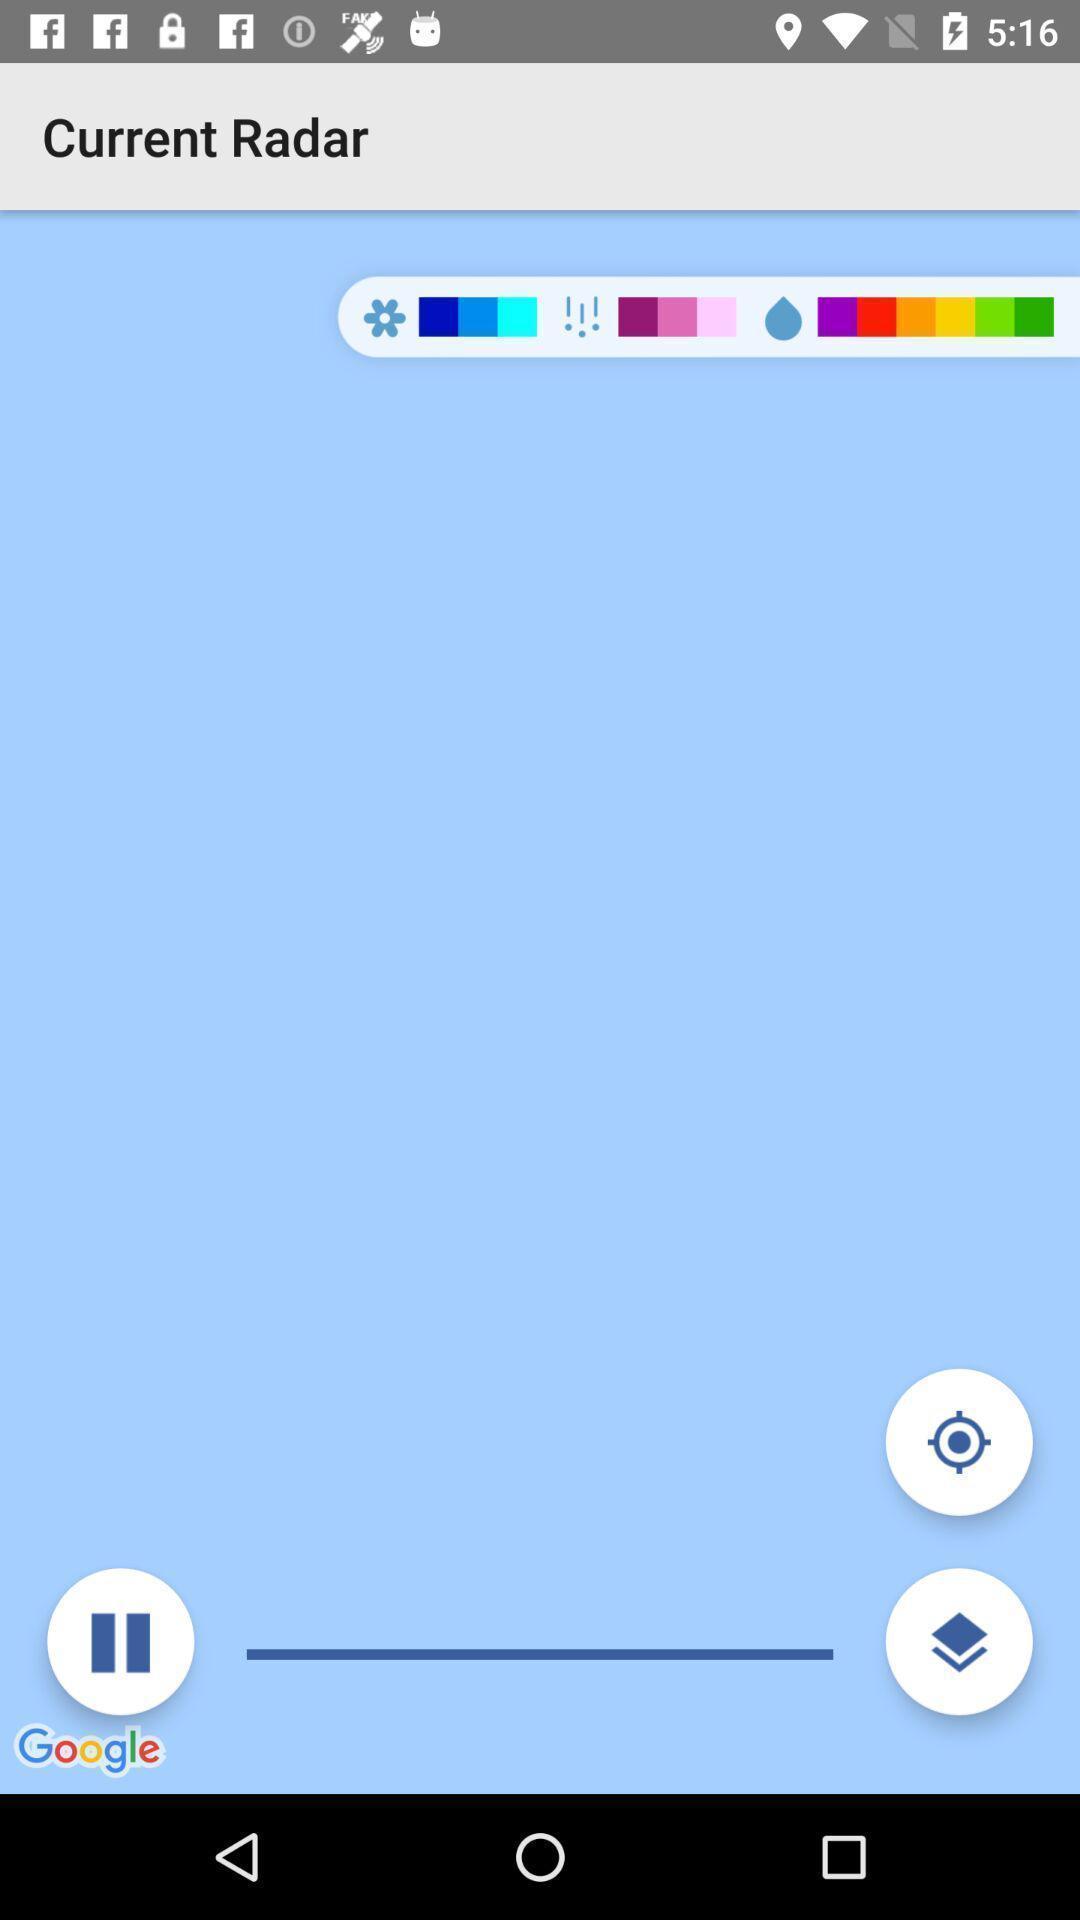Describe this image in words. Page is displaying current radar. 